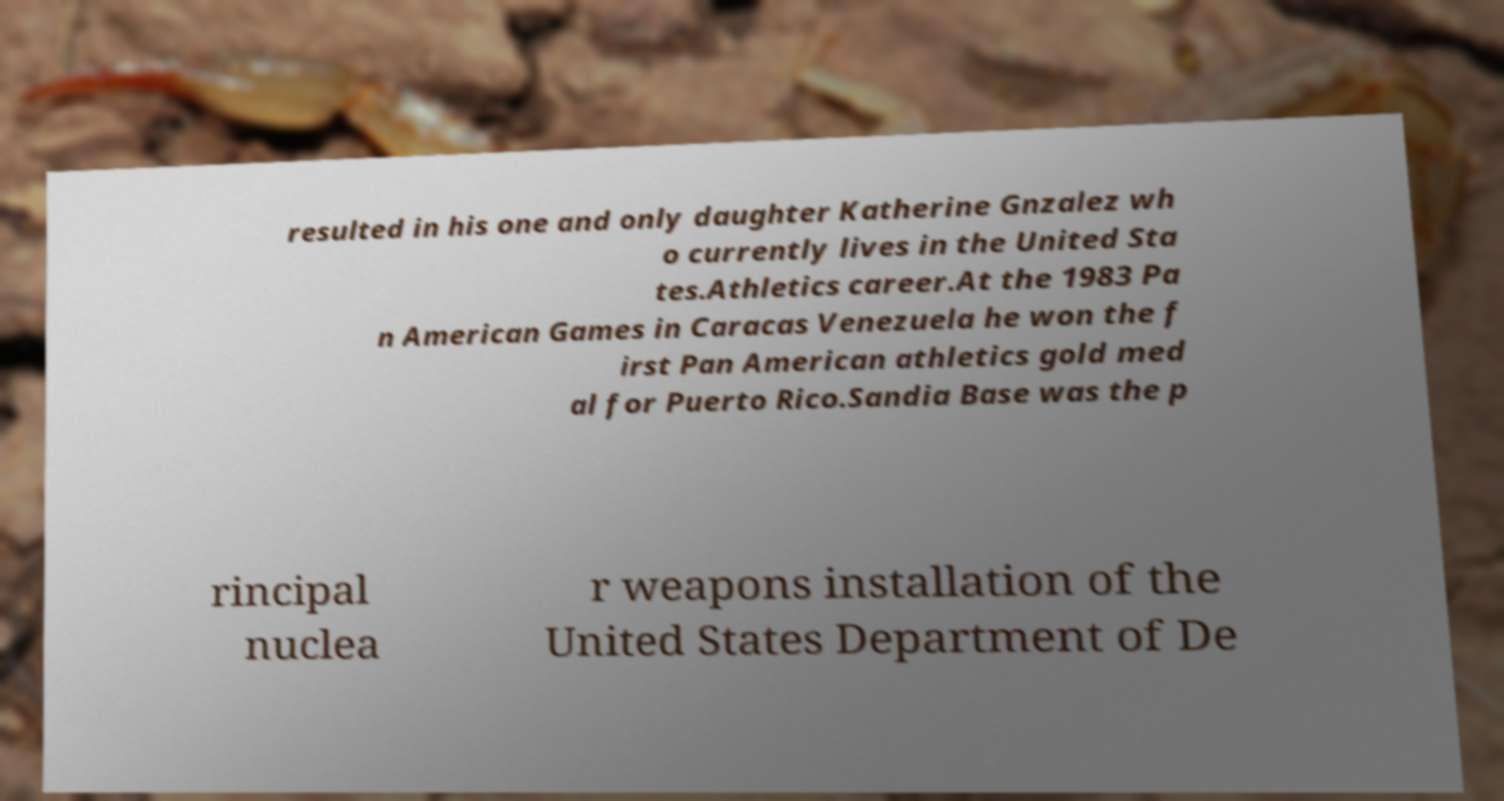Please identify and transcribe the text found in this image. resulted in his one and only daughter Katherine Gnzalez wh o currently lives in the United Sta tes.Athletics career.At the 1983 Pa n American Games in Caracas Venezuela he won the f irst Pan American athletics gold med al for Puerto Rico.Sandia Base was the p rincipal nuclea r weapons installation of the United States Department of De 